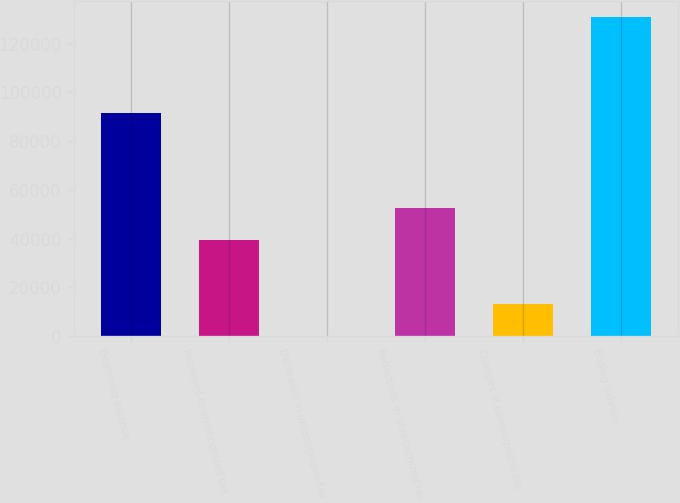<chart> <loc_0><loc_0><loc_500><loc_500><bar_chart><fcel>Beginning balance<fcel>Increases in unrecognized tax<fcel>Decreases in unrecognized tax<fcel>Reductions in unrecognized tax<fcel>Changes in unrecognized tax<fcel>Ending balance<nl><fcel>91765.8<fcel>39428.2<fcel>175<fcel>52512.6<fcel>13259.4<fcel>131019<nl></chart> 